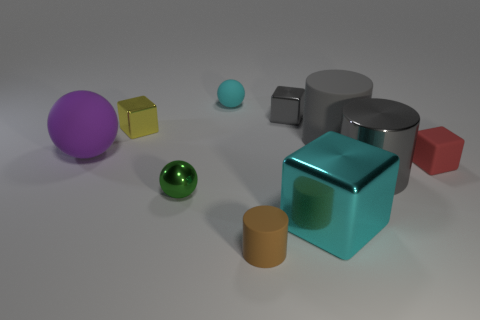Subtract 1 cubes. How many cubes are left? 3 Subtract all cylinders. How many objects are left? 7 Add 1 small rubber objects. How many small rubber objects exist? 4 Subtract 1 red blocks. How many objects are left? 9 Subtract all big gray things. Subtract all small cyan objects. How many objects are left? 7 Add 7 small red matte things. How many small red matte things are left? 8 